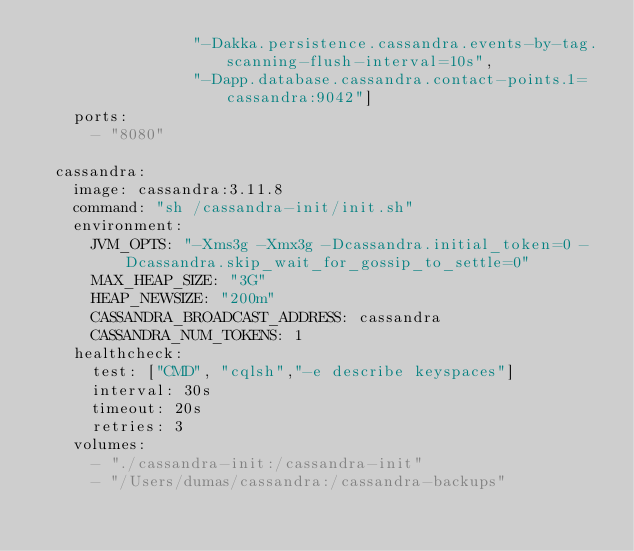Convert code to text. <code><loc_0><loc_0><loc_500><loc_500><_YAML_>                 "-Dakka.persistence.cassandra.events-by-tag.scanning-flush-interval=10s",
                 "-Dapp.database.cassandra.contact-points.1=cassandra:9042"]
    ports:
      - "8080"

  cassandra:
    image: cassandra:3.11.8
    command: "sh /cassandra-init/init.sh"
    environment:
      JVM_OPTS: "-Xms3g -Xmx3g -Dcassandra.initial_token=0 -Dcassandra.skip_wait_for_gossip_to_settle=0"
      MAX_HEAP_SIZE: "3G"
      HEAP_NEWSIZE: "200m"
      CASSANDRA_BROADCAST_ADDRESS: cassandra
      CASSANDRA_NUM_TOKENS: 1
    healthcheck:
      test: ["CMD", "cqlsh","-e describe keyspaces"]
      interval: 30s
      timeout: 20s
      retries: 3
    volumes:
      - "./cassandra-init:/cassandra-init"
      - "/Users/dumas/cassandra:/cassandra-backups"</code> 